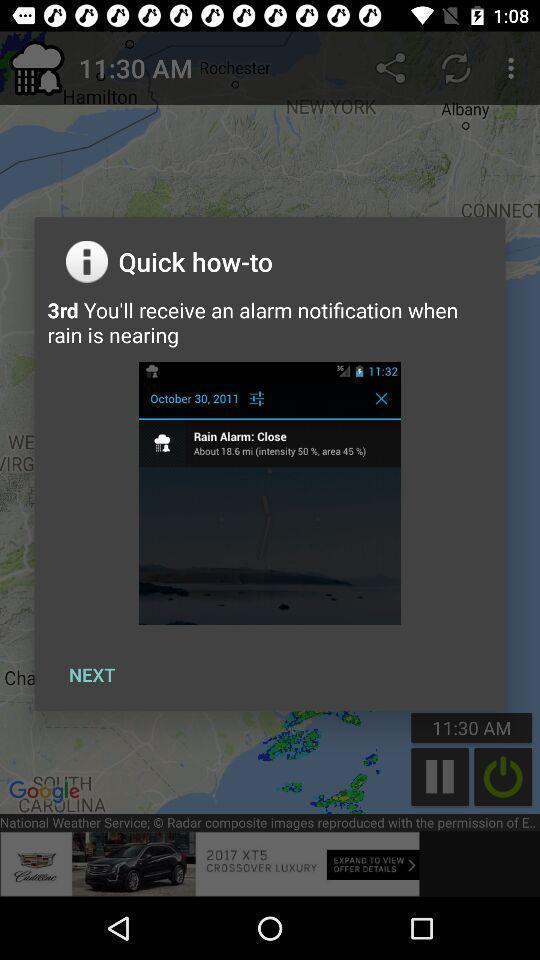Tell me about the visual elements in this screen capture. Pop-up displaying information about application. 